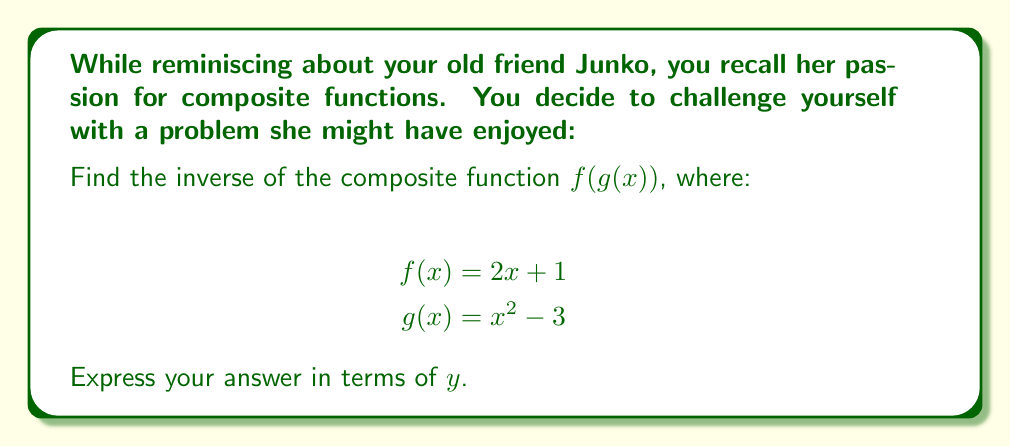What is the answer to this math problem? To find the inverse of a composite function, we follow these steps:

1) First, we compose $f(g(x))$:
   $$f(g(x)) = 2(x^2 - 3) + 1 = 2x^2 - 6 + 1 = 2x^2 - 5$$

2) Now, we find the inverse of this composite function:
   - Replace $f(g(x))$ with $y$:
     $$y = 2x^2 - 5$$
   
   - Swap $x$ and $y$:
     $$x = 2y^2 - 5$$
   
   - Solve for $y$:
     $$x + 5 = 2y^2$$
     $$\frac{x + 5}{2} = y^2$$
     $$y = \pm \sqrt{\frac{x + 5}{2}}$$

3) Since we want a function, we typically choose the positive root:
   $$y = \sqrt{\frac{x + 5}{2}}$$

This is the inverse of the composite function $f(g(x))$.
Answer: $y = \sqrt{\frac{x + 5}{2}}$ 